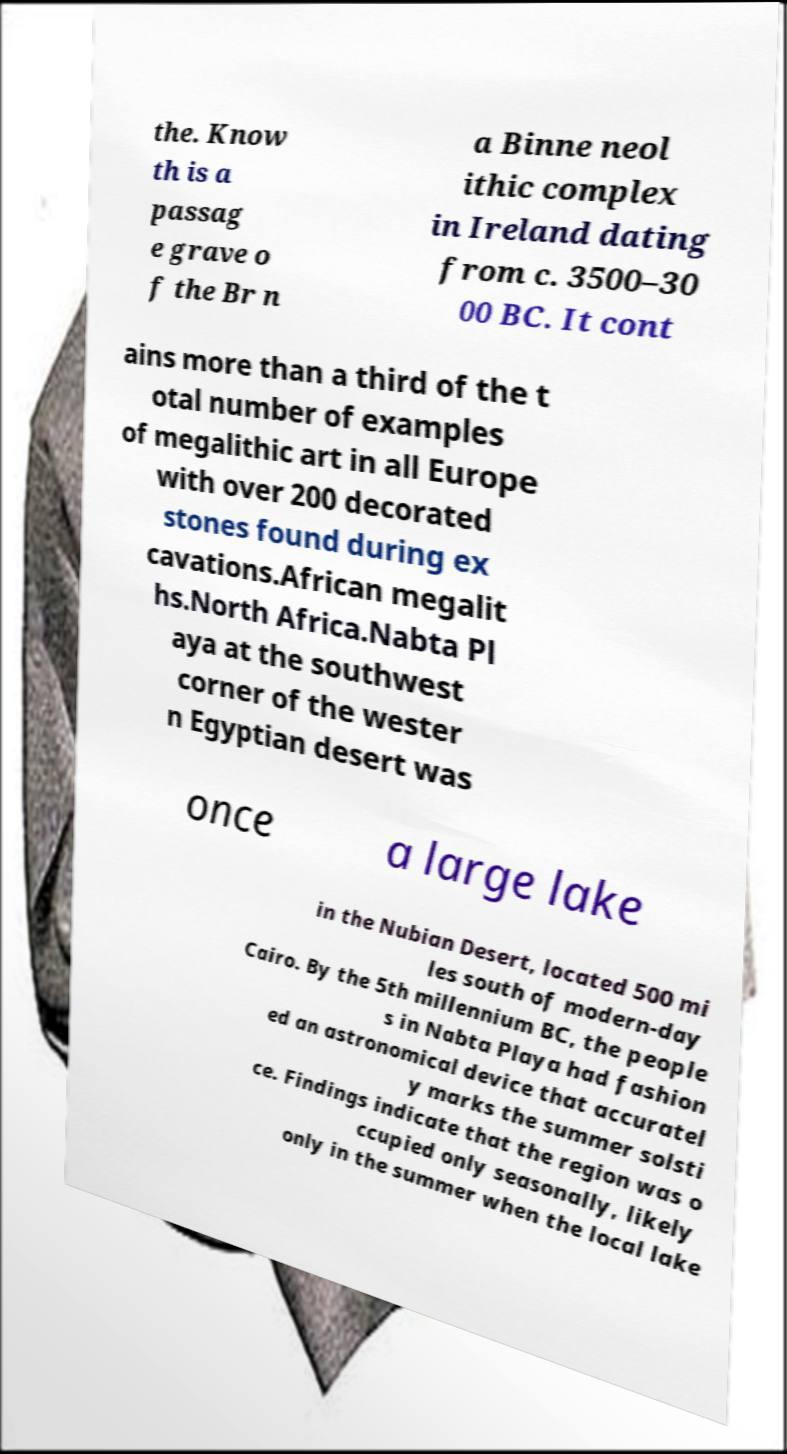I need the written content from this picture converted into text. Can you do that? the. Know th is a passag e grave o f the Br n a Binne neol ithic complex in Ireland dating from c. 3500–30 00 BC. It cont ains more than a third of the t otal number of examples of megalithic art in all Europe with over 200 decorated stones found during ex cavations.African megalit hs.North Africa.Nabta Pl aya at the southwest corner of the wester n Egyptian desert was once a large lake in the Nubian Desert, located 500 mi les south of modern-day Cairo. By the 5th millennium BC, the people s in Nabta Playa had fashion ed an astronomical device that accuratel y marks the summer solsti ce. Findings indicate that the region was o ccupied only seasonally, likely only in the summer when the local lake 